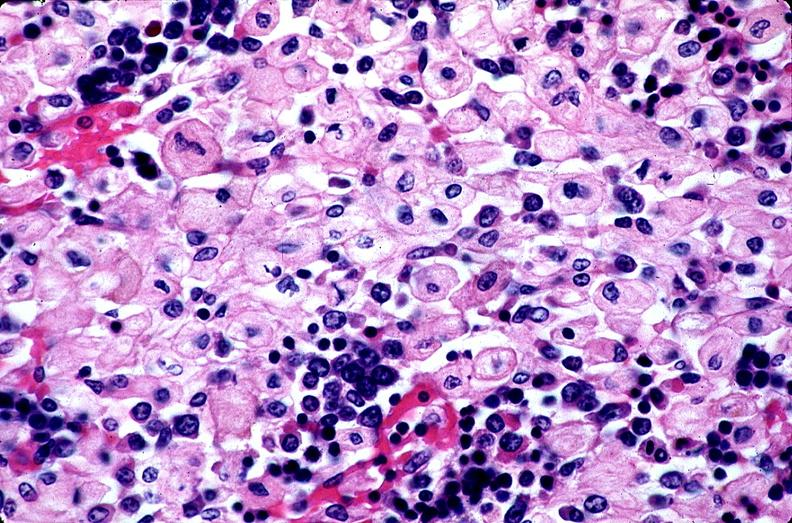what does this image show?
Answer the question using a single word or phrase. Gaucher disease 